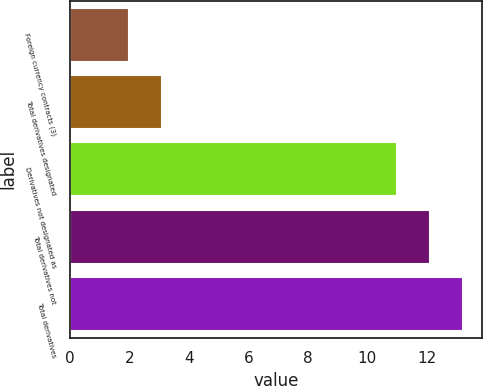<chart> <loc_0><loc_0><loc_500><loc_500><bar_chart><fcel>Foreign currency contracts (3)<fcel>Total derivatives designated<fcel>Derivatives not designated as<fcel>Total derivatives not<fcel>Total derivatives<nl><fcel>2<fcel>3.1<fcel>11<fcel>12.1<fcel>13.2<nl></chart> 